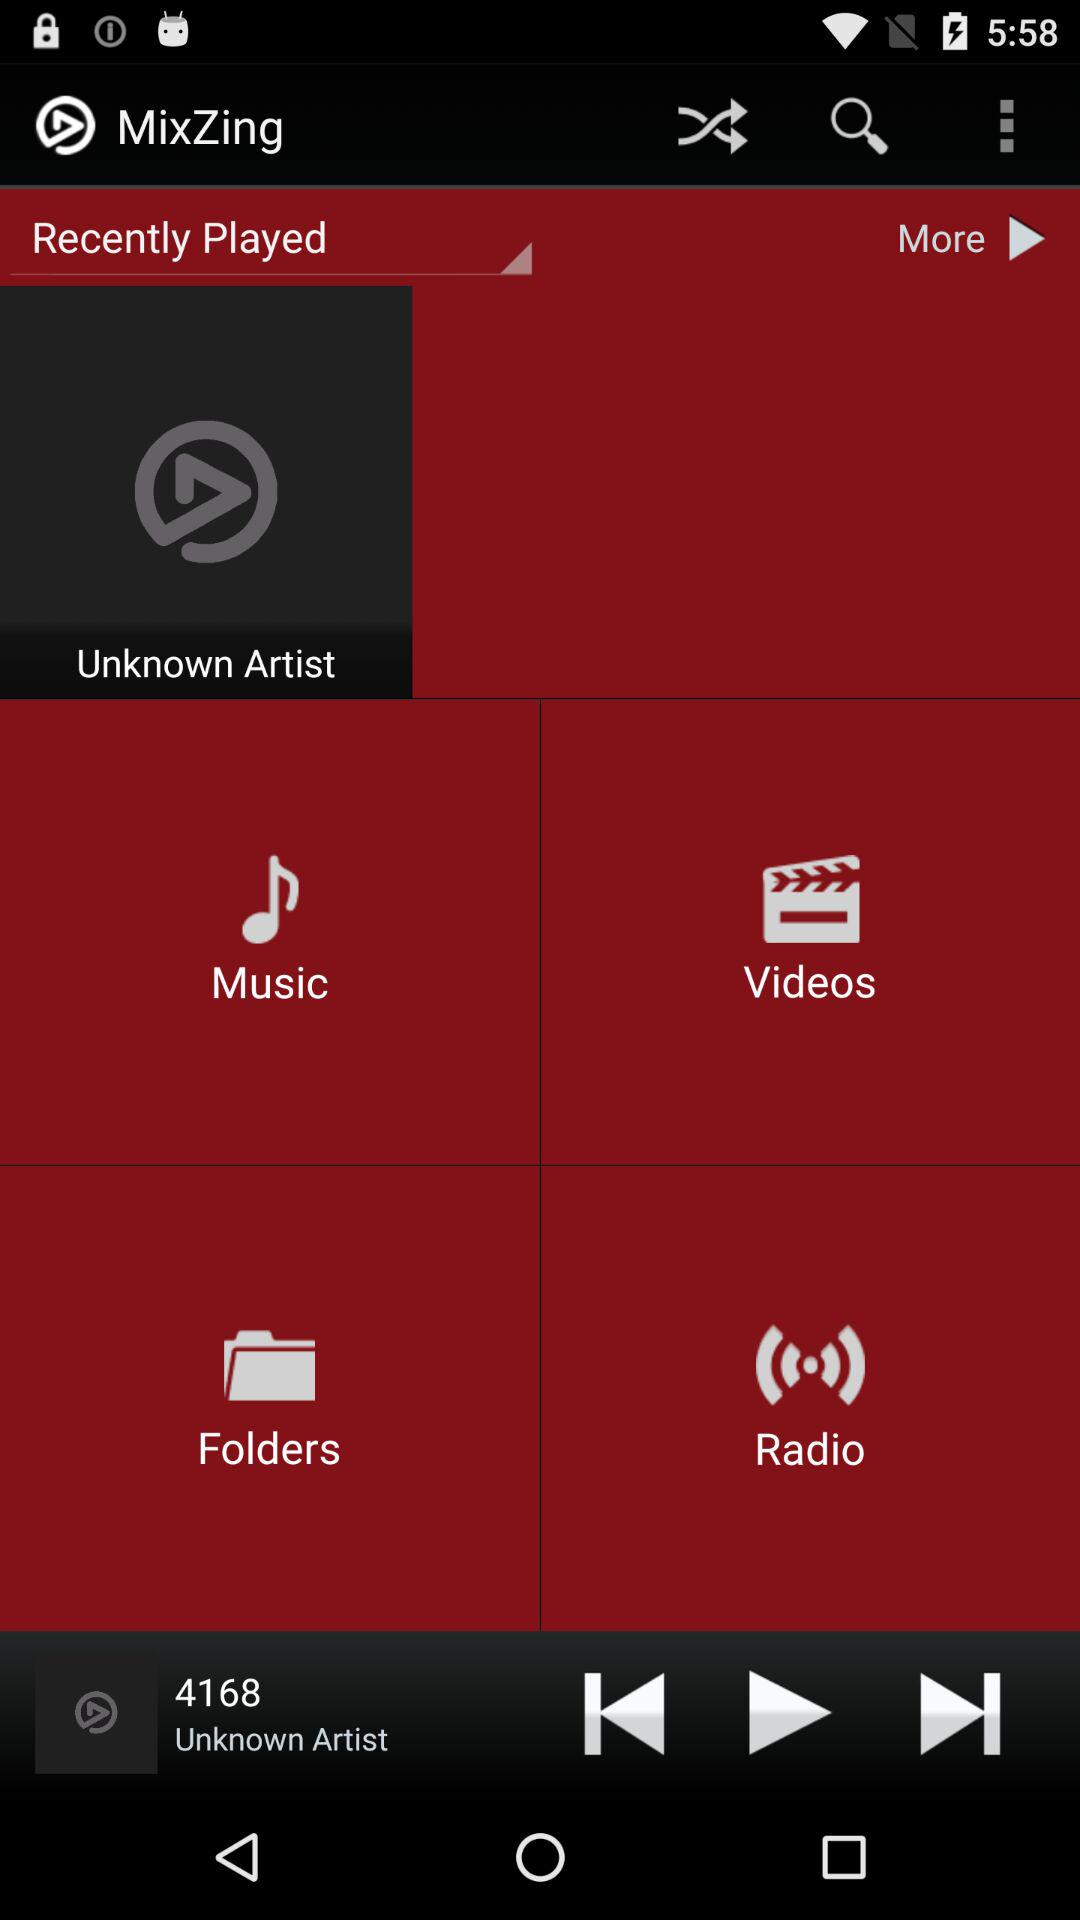Which audio is currently playing? The currently playing audio is 4168. 